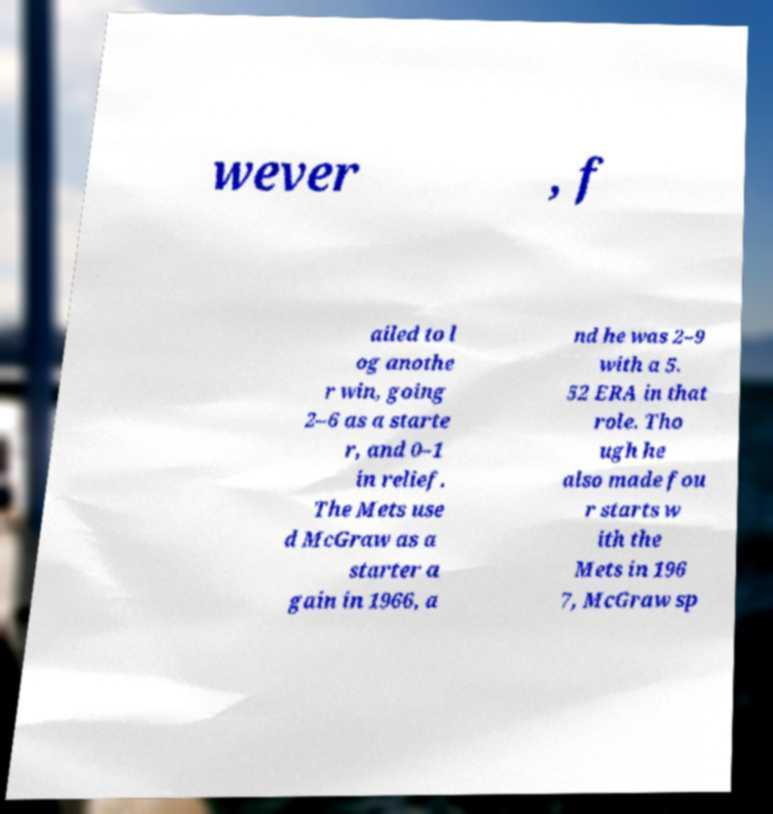Please identify and transcribe the text found in this image. wever , f ailed to l og anothe r win, going 2–6 as a starte r, and 0–1 in relief. The Mets use d McGraw as a starter a gain in 1966, a nd he was 2–9 with a 5. 52 ERA in that role. Tho ugh he also made fou r starts w ith the Mets in 196 7, McGraw sp 